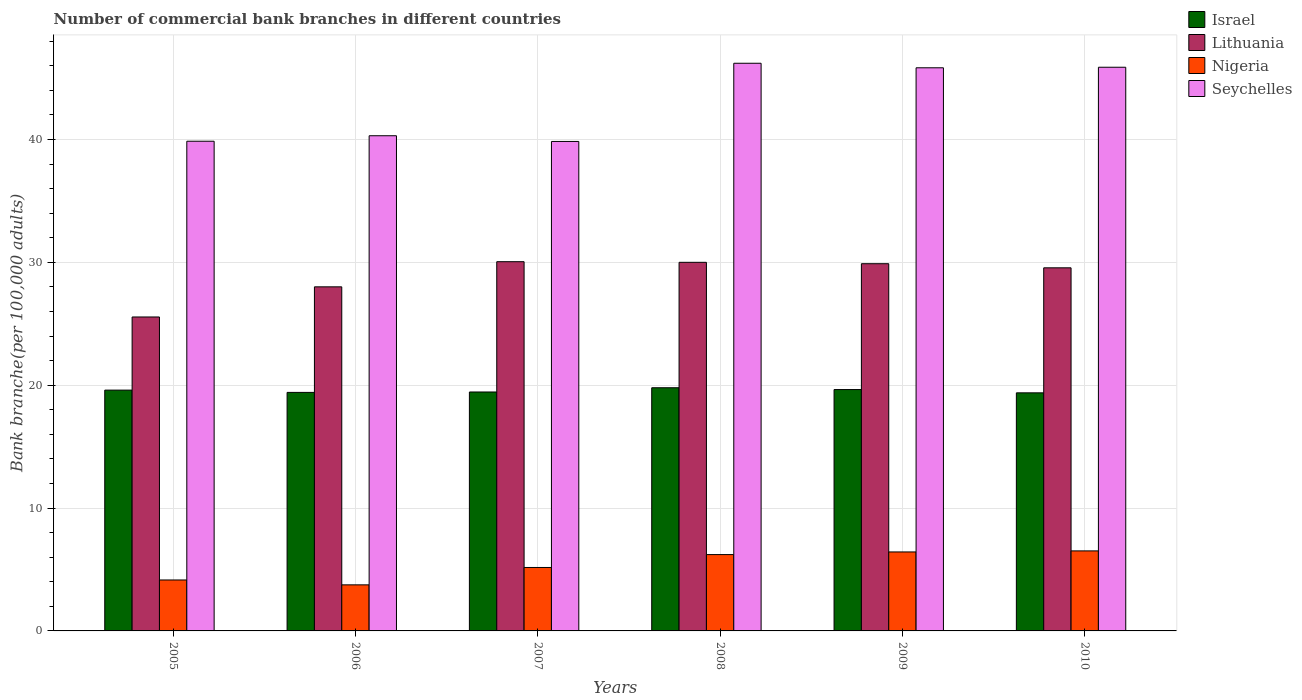How many different coloured bars are there?
Offer a terse response. 4. How many groups of bars are there?
Provide a succinct answer. 6. Are the number of bars on each tick of the X-axis equal?
Your answer should be compact. Yes. How many bars are there on the 5th tick from the right?
Give a very brief answer. 4. What is the label of the 4th group of bars from the left?
Provide a short and direct response. 2008. In how many cases, is the number of bars for a given year not equal to the number of legend labels?
Your answer should be compact. 0. What is the number of commercial bank branches in Lithuania in 2008?
Give a very brief answer. 30. Across all years, what is the maximum number of commercial bank branches in Seychelles?
Your answer should be very brief. 46.21. Across all years, what is the minimum number of commercial bank branches in Nigeria?
Your answer should be compact. 3.75. What is the total number of commercial bank branches in Nigeria in the graph?
Your response must be concise. 32.22. What is the difference between the number of commercial bank branches in Nigeria in 2008 and that in 2010?
Offer a very short reply. -0.3. What is the difference between the number of commercial bank branches in Nigeria in 2009 and the number of commercial bank branches in Israel in 2006?
Offer a terse response. -12.99. What is the average number of commercial bank branches in Lithuania per year?
Your response must be concise. 28.84. In the year 2006, what is the difference between the number of commercial bank branches in Seychelles and number of commercial bank branches in Lithuania?
Your answer should be compact. 12.3. In how many years, is the number of commercial bank branches in Lithuania greater than 38?
Your answer should be compact. 0. What is the ratio of the number of commercial bank branches in Seychelles in 2005 to that in 2010?
Ensure brevity in your answer.  0.87. Is the difference between the number of commercial bank branches in Seychelles in 2007 and 2010 greater than the difference between the number of commercial bank branches in Lithuania in 2007 and 2010?
Keep it short and to the point. No. What is the difference between the highest and the second highest number of commercial bank branches in Israel?
Offer a terse response. 0.15. What is the difference between the highest and the lowest number of commercial bank branches in Nigeria?
Your answer should be compact. 2.76. In how many years, is the number of commercial bank branches in Seychelles greater than the average number of commercial bank branches in Seychelles taken over all years?
Give a very brief answer. 3. What does the 1st bar from the left in 2009 represents?
Your answer should be compact. Israel. Is it the case that in every year, the sum of the number of commercial bank branches in Israel and number of commercial bank branches in Nigeria is greater than the number of commercial bank branches in Seychelles?
Offer a very short reply. No. How many years are there in the graph?
Offer a very short reply. 6. Are the values on the major ticks of Y-axis written in scientific E-notation?
Give a very brief answer. No. Does the graph contain any zero values?
Make the answer very short. No. Does the graph contain grids?
Give a very brief answer. Yes. Where does the legend appear in the graph?
Ensure brevity in your answer.  Top right. How are the legend labels stacked?
Your answer should be very brief. Vertical. What is the title of the graph?
Make the answer very short. Number of commercial bank branches in different countries. What is the label or title of the X-axis?
Offer a terse response. Years. What is the label or title of the Y-axis?
Offer a very short reply. Bank branche(per 100,0 adults). What is the Bank branche(per 100,000 adults) of Israel in 2005?
Offer a terse response. 19.6. What is the Bank branche(per 100,000 adults) of Lithuania in 2005?
Provide a short and direct response. 25.55. What is the Bank branche(per 100,000 adults) of Nigeria in 2005?
Provide a short and direct response. 4.15. What is the Bank branche(per 100,000 adults) in Seychelles in 2005?
Keep it short and to the point. 39.86. What is the Bank branche(per 100,000 adults) of Israel in 2006?
Your answer should be compact. 19.42. What is the Bank branche(per 100,000 adults) in Lithuania in 2006?
Provide a succinct answer. 28.01. What is the Bank branche(per 100,000 adults) in Nigeria in 2006?
Offer a very short reply. 3.75. What is the Bank branche(per 100,000 adults) in Seychelles in 2006?
Keep it short and to the point. 40.31. What is the Bank branche(per 100,000 adults) of Israel in 2007?
Keep it short and to the point. 19.45. What is the Bank branche(per 100,000 adults) of Lithuania in 2007?
Offer a very short reply. 30.05. What is the Bank branche(per 100,000 adults) in Nigeria in 2007?
Offer a terse response. 5.16. What is the Bank branche(per 100,000 adults) of Seychelles in 2007?
Offer a terse response. 39.84. What is the Bank branche(per 100,000 adults) of Israel in 2008?
Ensure brevity in your answer.  19.79. What is the Bank branche(per 100,000 adults) in Lithuania in 2008?
Your answer should be very brief. 30. What is the Bank branche(per 100,000 adults) in Nigeria in 2008?
Offer a very short reply. 6.21. What is the Bank branche(per 100,000 adults) of Seychelles in 2008?
Your answer should be compact. 46.21. What is the Bank branche(per 100,000 adults) of Israel in 2009?
Make the answer very short. 19.65. What is the Bank branche(per 100,000 adults) of Lithuania in 2009?
Provide a succinct answer. 29.89. What is the Bank branche(per 100,000 adults) of Nigeria in 2009?
Offer a very short reply. 6.43. What is the Bank branche(per 100,000 adults) of Seychelles in 2009?
Your answer should be very brief. 45.84. What is the Bank branche(per 100,000 adults) in Israel in 2010?
Offer a very short reply. 19.38. What is the Bank branche(per 100,000 adults) of Lithuania in 2010?
Keep it short and to the point. 29.56. What is the Bank branche(per 100,000 adults) of Nigeria in 2010?
Ensure brevity in your answer.  6.51. What is the Bank branche(per 100,000 adults) in Seychelles in 2010?
Your answer should be very brief. 45.88. Across all years, what is the maximum Bank branche(per 100,000 adults) of Israel?
Offer a very short reply. 19.79. Across all years, what is the maximum Bank branche(per 100,000 adults) in Lithuania?
Offer a terse response. 30.05. Across all years, what is the maximum Bank branche(per 100,000 adults) of Nigeria?
Offer a very short reply. 6.51. Across all years, what is the maximum Bank branche(per 100,000 adults) of Seychelles?
Offer a terse response. 46.21. Across all years, what is the minimum Bank branche(per 100,000 adults) of Israel?
Offer a very short reply. 19.38. Across all years, what is the minimum Bank branche(per 100,000 adults) of Lithuania?
Offer a very short reply. 25.55. Across all years, what is the minimum Bank branche(per 100,000 adults) in Nigeria?
Offer a terse response. 3.75. Across all years, what is the minimum Bank branche(per 100,000 adults) in Seychelles?
Keep it short and to the point. 39.84. What is the total Bank branche(per 100,000 adults) of Israel in the graph?
Offer a terse response. 117.29. What is the total Bank branche(per 100,000 adults) of Lithuania in the graph?
Ensure brevity in your answer.  173.07. What is the total Bank branche(per 100,000 adults) of Nigeria in the graph?
Your answer should be compact. 32.22. What is the total Bank branche(per 100,000 adults) of Seychelles in the graph?
Give a very brief answer. 257.94. What is the difference between the Bank branche(per 100,000 adults) of Israel in 2005 and that in 2006?
Keep it short and to the point. 0.18. What is the difference between the Bank branche(per 100,000 adults) of Lithuania in 2005 and that in 2006?
Your answer should be compact. -2.45. What is the difference between the Bank branche(per 100,000 adults) in Nigeria in 2005 and that in 2006?
Make the answer very short. 0.4. What is the difference between the Bank branche(per 100,000 adults) in Seychelles in 2005 and that in 2006?
Ensure brevity in your answer.  -0.45. What is the difference between the Bank branche(per 100,000 adults) of Israel in 2005 and that in 2007?
Your answer should be very brief. 0.15. What is the difference between the Bank branche(per 100,000 adults) of Nigeria in 2005 and that in 2007?
Offer a very short reply. -1.02. What is the difference between the Bank branche(per 100,000 adults) of Seychelles in 2005 and that in 2007?
Offer a terse response. 0.02. What is the difference between the Bank branche(per 100,000 adults) in Israel in 2005 and that in 2008?
Keep it short and to the point. -0.19. What is the difference between the Bank branche(per 100,000 adults) of Lithuania in 2005 and that in 2008?
Your response must be concise. -4.45. What is the difference between the Bank branche(per 100,000 adults) of Nigeria in 2005 and that in 2008?
Ensure brevity in your answer.  -2.07. What is the difference between the Bank branche(per 100,000 adults) in Seychelles in 2005 and that in 2008?
Your response must be concise. -6.35. What is the difference between the Bank branche(per 100,000 adults) in Israel in 2005 and that in 2009?
Offer a terse response. -0.05. What is the difference between the Bank branche(per 100,000 adults) of Lithuania in 2005 and that in 2009?
Make the answer very short. -4.34. What is the difference between the Bank branche(per 100,000 adults) of Nigeria in 2005 and that in 2009?
Provide a short and direct response. -2.28. What is the difference between the Bank branche(per 100,000 adults) in Seychelles in 2005 and that in 2009?
Provide a short and direct response. -5.98. What is the difference between the Bank branche(per 100,000 adults) in Israel in 2005 and that in 2010?
Give a very brief answer. 0.22. What is the difference between the Bank branche(per 100,000 adults) in Lithuania in 2005 and that in 2010?
Ensure brevity in your answer.  -4. What is the difference between the Bank branche(per 100,000 adults) in Nigeria in 2005 and that in 2010?
Offer a terse response. -2.37. What is the difference between the Bank branche(per 100,000 adults) of Seychelles in 2005 and that in 2010?
Your response must be concise. -6.02. What is the difference between the Bank branche(per 100,000 adults) in Israel in 2006 and that in 2007?
Offer a very short reply. -0.03. What is the difference between the Bank branche(per 100,000 adults) in Lithuania in 2006 and that in 2007?
Your answer should be compact. -2.05. What is the difference between the Bank branche(per 100,000 adults) in Nigeria in 2006 and that in 2007?
Keep it short and to the point. -1.41. What is the difference between the Bank branche(per 100,000 adults) in Seychelles in 2006 and that in 2007?
Provide a succinct answer. 0.46. What is the difference between the Bank branche(per 100,000 adults) in Israel in 2006 and that in 2008?
Keep it short and to the point. -0.38. What is the difference between the Bank branche(per 100,000 adults) in Lithuania in 2006 and that in 2008?
Make the answer very short. -2. What is the difference between the Bank branche(per 100,000 adults) in Nigeria in 2006 and that in 2008?
Ensure brevity in your answer.  -2.46. What is the difference between the Bank branche(per 100,000 adults) in Seychelles in 2006 and that in 2008?
Offer a terse response. -5.9. What is the difference between the Bank branche(per 100,000 adults) in Israel in 2006 and that in 2009?
Your response must be concise. -0.23. What is the difference between the Bank branche(per 100,000 adults) in Lithuania in 2006 and that in 2009?
Make the answer very short. -1.88. What is the difference between the Bank branche(per 100,000 adults) of Nigeria in 2006 and that in 2009?
Provide a succinct answer. -2.68. What is the difference between the Bank branche(per 100,000 adults) in Seychelles in 2006 and that in 2009?
Offer a very short reply. -5.53. What is the difference between the Bank branche(per 100,000 adults) in Israel in 2006 and that in 2010?
Offer a very short reply. 0.04. What is the difference between the Bank branche(per 100,000 adults) in Lithuania in 2006 and that in 2010?
Offer a very short reply. -1.55. What is the difference between the Bank branche(per 100,000 adults) in Nigeria in 2006 and that in 2010?
Give a very brief answer. -2.76. What is the difference between the Bank branche(per 100,000 adults) of Seychelles in 2006 and that in 2010?
Your answer should be very brief. -5.58. What is the difference between the Bank branche(per 100,000 adults) of Israel in 2007 and that in 2008?
Provide a short and direct response. -0.35. What is the difference between the Bank branche(per 100,000 adults) of Lithuania in 2007 and that in 2008?
Your response must be concise. 0.05. What is the difference between the Bank branche(per 100,000 adults) in Nigeria in 2007 and that in 2008?
Offer a very short reply. -1.05. What is the difference between the Bank branche(per 100,000 adults) in Seychelles in 2007 and that in 2008?
Make the answer very short. -6.36. What is the difference between the Bank branche(per 100,000 adults) of Israel in 2007 and that in 2009?
Your response must be concise. -0.2. What is the difference between the Bank branche(per 100,000 adults) of Lithuania in 2007 and that in 2009?
Your answer should be compact. 0.16. What is the difference between the Bank branche(per 100,000 adults) of Nigeria in 2007 and that in 2009?
Ensure brevity in your answer.  -1.26. What is the difference between the Bank branche(per 100,000 adults) in Seychelles in 2007 and that in 2009?
Ensure brevity in your answer.  -6. What is the difference between the Bank branche(per 100,000 adults) in Israel in 2007 and that in 2010?
Give a very brief answer. 0.07. What is the difference between the Bank branche(per 100,000 adults) in Lithuania in 2007 and that in 2010?
Give a very brief answer. 0.5. What is the difference between the Bank branche(per 100,000 adults) of Nigeria in 2007 and that in 2010?
Ensure brevity in your answer.  -1.35. What is the difference between the Bank branche(per 100,000 adults) of Seychelles in 2007 and that in 2010?
Give a very brief answer. -6.04. What is the difference between the Bank branche(per 100,000 adults) in Israel in 2008 and that in 2009?
Provide a short and direct response. 0.15. What is the difference between the Bank branche(per 100,000 adults) of Lithuania in 2008 and that in 2009?
Make the answer very short. 0.11. What is the difference between the Bank branche(per 100,000 adults) of Nigeria in 2008 and that in 2009?
Your response must be concise. -0.21. What is the difference between the Bank branche(per 100,000 adults) of Seychelles in 2008 and that in 2009?
Keep it short and to the point. 0.37. What is the difference between the Bank branche(per 100,000 adults) in Israel in 2008 and that in 2010?
Make the answer very short. 0.42. What is the difference between the Bank branche(per 100,000 adults) of Lithuania in 2008 and that in 2010?
Keep it short and to the point. 0.45. What is the difference between the Bank branche(per 100,000 adults) of Nigeria in 2008 and that in 2010?
Your answer should be very brief. -0.3. What is the difference between the Bank branche(per 100,000 adults) in Seychelles in 2008 and that in 2010?
Provide a short and direct response. 0.32. What is the difference between the Bank branche(per 100,000 adults) of Israel in 2009 and that in 2010?
Offer a very short reply. 0.27. What is the difference between the Bank branche(per 100,000 adults) in Lithuania in 2009 and that in 2010?
Offer a very short reply. 0.33. What is the difference between the Bank branche(per 100,000 adults) of Nigeria in 2009 and that in 2010?
Offer a very short reply. -0.08. What is the difference between the Bank branche(per 100,000 adults) in Seychelles in 2009 and that in 2010?
Keep it short and to the point. -0.05. What is the difference between the Bank branche(per 100,000 adults) in Israel in 2005 and the Bank branche(per 100,000 adults) in Lithuania in 2006?
Give a very brief answer. -8.41. What is the difference between the Bank branche(per 100,000 adults) in Israel in 2005 and the Bank branche(per 100,000 adults) in Nigeria in 2006?
Your answer should be very brief. 15.85. What is the difference between the Bank branche(per 100,000 adults) in Israel in 2005 and the Bank branche(per 100,000 adults) in Seychelles in 2006?
Offer a very short reply. -20.71. What is the difference between the Bank branche(per 100,000 adults) in Lithuania in 2005 and the Bank branche(per 100,000 adults) in Nigeria in 2006?
Your answer should be very brief. 21.81. What is the difference between the Bank branche(per 100,000 adults) in Lithuania in 2005 and the Bank branche(per 100,000 adults) in Seychelles in 2006?
Your answer should be compact. -14.75. What is the difference between the Bank branche(per 100,000 adults) of Nigeria in 2005 and the Bank branche(per 100,000 adults) of Seychelles in 2006?
Provide a short and direct response. -36.16. What is the difference between the Bank branche(per 100,000 adults) of Israel in 2005 and the Bank branche(per 100,000 adults) of Lithuania in 2007?
Provide a succinct answer. -10.45. What is the difference between the Bank branche(per 100,000 adults) of Israel in 2005 and the Bank branche(per 100,000 adults) of Nigeria in 2007?
Offer a terse response. 14.44. What is the difference between the Bank branche(per 100,000 adults) in Israel in 2005 and the Bank branche(per 100,000 adults) in Seychelles in 2007?
Keep it short and to the point. -20.24. What is the difference between the Bank branche(per 100,000 adults) in Lithuania in 2005 and the Bank branche(per 100,000 adults) in Nigeria in 2007?
Provide a short and direct response. 20.39. What is the difference between the Bank branche(per 100,000 adults) in Lithuania in 2005 and the Bank branche(per 100,000 adults) in Seychelles in 2007?
Provide a short and direct response. -14.29. What is the difference between the Bank branche(per 100,000 adults) of Nigeria in 2005 and the Bank branche(per 100,000 adults) of Seychelles in 2007?
Make the answer very short. -35.7. What is the difference between the Bank branche(per 100,000 adults) of Israel in 2005 and the Bank branche(per 100,000 adults) of Lithuania in 2008?
Your answer should be compact. -10.4. What is the difference between the Bank branche(per 100,000 adults) of Israel in 2005 and the Bank branche(per 100,000 adults) of Nigeria in 2008?
Offer a terse response. 13.39. What is the difference between the Bank branche(per 100,000 adults) of Israel in 2005 and the Bank branche(per 100,000 adults) of Seychelles in 2008?
Give a very brief answer. -26.61. What is the difference between the Bank branche(per 100,000 adults) of Lithuania in 2005 and the Bank branche(per 100,000 adults) of Nigeria in 2008?
Your answer should be compact. 19.34. What is the difference between the Bank branche(per 100,000 adults) in Lithuania in 2005 and the Bank branche(per 100,000 adults) in Seychelles in 2008?
Keep it short and to the point. -20.65. What is the difference between the Bank branche(per 100,000 adults) in Nigeria in 2005 and the Bank branche(per 100,000 adults) in Seychelles in 2008?
Provide a succinct answer. -42.06. What is the difference between the Bank branche(per 100,000 adults) of Israel in 2005 and the Bank branche(per 100,000 adults) of Lithuania in 2009?
Provide a succinct answer. -10.29. What is the difference between the Bank branche(per 100,000 adults) in Israel in 2005 and the Bank branche(per 100,000 adults) in Nigeria in 2009?
Your response must be concise. 13.17. What is the difference between the Bank branche(per 100,000 adults) in Israel in 2005 and the Bank branche(per 100,000 adults) in Seychelles in 2009?
Ensure brevity in your answer.  -26.24. What is the difference between the Bank branche(per 100,000 adults) of Lithuania in 2005 and the Bank branche(per 100,000 adults) of Nigeria in 2009?
Keep it short and to the point. 19.13. What is the difference between the Bank branche(per 100,000 adults) of Lithuania in 2005 and the Bank branche(per 100,000 adults) of Seychelles in 2009?
Your answer should be very brief. -20.28. What is the difference between the Bank branche(per 100,000 adults) in Nigeria in 2005 and the Bank branche(per 100,000 adults) in Seychelles in 2009?
Your answer should be compact. -41.69. What is the difference between the Bank branche(per 100,000 adults) in Israel in 2005 and the Bank branche(per 100,000 adults) in Lithuania in 2010?
Your answer should be very brief. -9.96. What is the difference between the Bank branche(per 100,000 adults) in Israel in 2005 and the Bank branche(per 100,000 adults) in Nigeria in 2010?
Give a very brief answer. 13.09. What is the difference between the Bank branche(per 100,000 adults) in Israel in 2005 and the Bank branche(per 100,000 adults) in Seychelles in 2010?
Make the answer very short. -26.28. What is the difference between the Bank branche(per 100,000 adults) in Lithuania in 2005 and the Bank branche(per 100,000 adults) in Nigeria in 2010?
Offer a terse response. 19.04. What is the difference between the Bank branche(per 100,000 adults) of Lithuania in 2005 and the Bank branche(per 100,000 adults) of Seychelles in 2010?
Your answer should be compact. -20.33. What is the difference between the Bank branche(per 100,000 adults) of Nigeria in 2005 and the Bank branche(per 100,000 adults) of Seychelles in 2010?
Give a very brief answer. -41.74. What is the difference between the Bank branche(per 100,000 adults) in Israel in 2006 and the Bank branche(per 100,000 adults) in Lithuania in 2007?
Provide a short and direct response. -10.64. What is the difference between the Bank branche(per 100,000 adults) of Israel in 2006 and the Bank branche(per 100,000 adults) of Nigeria in 2007?
Your answer should be compact. 14.25. What is the difference between the Bank branche(per 100,000 adults) of Israel in 2006 and the Bank branche(per 100,000 adults) of Seychelles in 2007?
Your answer should be compact. -20.43. What is the difference between the Bank branche(per 100,000 adults) in Lithuania in 2006 and the Bank branche(per 100,000 adults) in Nigeria in 2007?
Make the answer very short. 22.84. What is the difference between the Bank branche(per 100,000 adults) of Lithuania in 2006 and the Bank branche(per 100,000 adults) of Seychelles in 2007?
Make the answer very short. -11.83. What is the difference between the Bank branche(per 100,000 adults) of Nigeria in 2006 and the Bank branche(per 100,000 adults) of Seychelles in 2007?
Provide a short and direct response. -36.09. What is the difference between the Bank branche(per 100,000 adults) in Israel in 2006 and the Bank branche(per 100,000 adults) in Lithuania in 2008?
Provide a succinct answer. -10.59. What is the difference between the Bank branche(per 100,000 adults) in Israel in 2006 and the Bank branche(per 100,000 adults) in Nigeria in 2008?
Your answer should be very brief. 13.2. What is the difference between the Bank branche(per 100,000 adults) of Israel in 2006 and the Bank branche(per 100,000 adults) of Seychelles in 2008?
Your answer should be compact. -26.79. What is the difference between the Bank branche(per 100,000 adults) in Lithuania in 2006 and the Bank branche(per 100,000 adults) in Nigeria in 2008?
Provide a short and direct response. 21.79. What is the difference between the Bank branche(per 100,000 adults) in Lithuania in 2006 and the Bank branche(per 100,000 adults) in Seychelles in 2008?
Ensure brevity in your answer.  -18.2. What is the difference between the Bank branche(per 100,000 adults) in Nigeria in 2006 and the Bank branche(per 100,000 adults) in Seychelles in 2008?
Offer a very short reply. -42.46. What is the difference between the Bank branche(per 100,000 adults) of Israel in 2006 and the Bank branche(per 100,000 adults) of Lithuania in 2009?
Your answer should be compact. -10.47. What is the difference between the Bank branche(per 100,000 adults) in Israel in 2006 and the Bank branche(per 100,000 adults) in Nigeria in 2009?
Your response must be concise. 12.99. What is the difference between the Bank branche(per 100,000 adults) in Israel in 2006 and the Bank branche(per 100,000 adults) in Seychelles in 2009?
Offer a terse response. -26.42. What is the difference between the Bank branche(per 100,000 adults) of Lithuania in 2006 and the Bank branche(per 100,000 adults) of Nigeria in 2009?
Give a very brief answer. 21.58. What is the difference between the Bank branche(per 100,000 adults) of Lithuania in 2006 and the Bank branche(per 100,000 adults) of Seychelles in 2009?
Offer a very short reply. -17.83. What is the difference between the Bank branche(per 100,000 adults) of Nigeria in 2006 and the Bank branche(per 100,000 adults) of Seychelles in 2009?
Your answer should be very brief. -42.09. What is the difference between the Bank branche(per 100,000 adults) of Israel in 2006 and the Bank branche(per 100,000 adults) of Lithuania in 2010?
Your answer should be compact. -10.14. What is the difference between the Bank branche(per 100,000 adults) of Israel in 2006 and the Bank branche(per 100,000 adults) of Nigeria in 2010?
Make the answer very short. 12.9. What is the difference between the Bank branche(per 100,000 adults) in Israel in 2006 and the Bank branche(per 100,000 adults) in Seychelles in 2010?
Your response must be concise. -26.47. What is the difference between the Bank branche(per 100,000 adults) of Lithuania in 2006 and the Bank branche(per 100,000 adults) of Nigeria in 2010?
Give a very brief answer. 21.5. What is the difference between the Bank branche(per 100,000 adults) of Lithuania in 2006 and the Bank branche(per 100,000 adults) of Seychelles in 2010?
Provide a succinct answer. -17.88. What is the difference between the Bank branche(per 100,000 adults) in Nigeria in 2006 and the Bank branche(per 100,000 adults) in Seychelles in 2010?
Provide a short and direct response. -42.13. What is the difference between the Bank branche(per 100,000 adults) of Israel in 2007 and the Bank branche(per 100,000 adults) of Lithuania in 2008?
Offer a very short reply. -10.55. What is the difference between the Bank branche(per 100,000 adults) of Israel in 2007 and the Bank branche(per 100,000 adults) of Nigeria in 2008?
Offer a terse response. 13.23. What is the difference between the Bank branche(per 100,000 adults) in Israel in 2007 and the Bank branche(per 100,000 adults) in Seychelles in 2008?
Provide a succinct answer. -26.76. What is the difference between the Bank branche(per 100,000 adults) of Lithuania in 2007 and the Bank branche(per 100,000 adults) of Nigeria in 2008?
Offer a terse response. 23.84. What is the difference between the Bank branche(per 100,000 adults) of Lithuania in 2007 and the Bank branche(per 100,000 adults) of Seychelles in 2008?
Offer a terse response. -16.15. What is the difference between the Bank branche(per 100,000 adults) of Nigeria in 2007 and the Bank branche(per 100,000 adults) of Seychelles in 2008?
Your response must be concise. -41.04. What is the difference between the Bank branche(per 100,000 adults) of Israel in 2007 and the Bank branche(per 100,000 adults) of Lithuania in 2009?
Provide a short and direct response. -10.44. What is the difference between the Bank branche(per 100,000 adults) in Israel in 2007 and the Bank branche(per 100,000 adults) in Nigeria in 2009?
Your response must be concise. 13.02. What is the difference between the Bank branche(per 100,000 adults) in Israel in 2007 and the Bank branche(per 100,000 adults) in Seychelles in 2009?
Keep it short and to the point. -26.39. What is the difference between the Bank branche(per 100,000 adults) of Lithuania in 2007 and the Bank branche(per 100,000 adults) of Nigeria in 2009?
Your answer should be very brief. 23.63. What is the difference between the Bank branche(per 100,000 adults) of Lithuania in 2007 and the Bank branche(per 100,000 adults) of Seychelles in 2009?
Give a very brief answer. -15.78. What is the difference between the Bank branche(per 100,000 adults) in Nigeria in 2007 and the Bank branche(per 100,000 adults) in Seychelles in 2009?
Your answer should be very brief. -40.67. What is the difference between the Bank branche(per 100,000 adults) of Israel in 2007 and the Bank branche(per 100,000 adults) of Lithuania in 2010?
Your answer should be compact. -10.11. What is the difference between the Bank branche(per 100,000 adults) of Israel in 2007 and the Bank branche(per 100,000 adults) of Nigeria in 2010?
Your answer should be compact. 12.94. What is the difference between the Bank branche(per 100,000 adults) in Israel in 2007 and the Bank branche(per 100,000 adults) in Seychelles in 2010?
Make the answer very short. -26.43. What is the difference between the Bank branche(per 100,000 adults) of Lithuania in 2007 and the Bank branche(per 100,000 adults) of Nigeria in 2010?
Offer a very short reply. 23.54. What is the difference between the Bank branche(per 100,000 adults) of Lithuania in 2007 and the Bank branche(per 100,000 adults) of Seychelles in 2010?
Your answer should be very brief. -15.83. What is the difference between the Bank branche(per 100,000 adults) of Nigeria in 2007 and the Bank branche(per 100,000 adults) of Seychelles in 2010?
Make the answer very short. -40.72. What is the difference between the Bank branche(per 100,000 adults) of Israel in 2008 and the Bank branche(per 100,000 adults) of Lithuania in 2009?
Offer a very short reply. -10.1. What is the difference between the Bank branche(per 100,000 adults) of Israel in 2008 and the Bank branche(per 100,000 adults) of Nigeria in 2009?
Offer a terse response. 13.37. What is the difference between the Bank branche(per 100,000 adults) of Israel in 2008 and the Bank branche(per 100,000 adults) of Seychelles in 2009?
Ensure brevity in your answer.  -26.04. What is the difference between the Bank branche(per 100,000 adults) in Lithuania in 2008 and the Bank branche(per 100,000 adults) in Nigeria in 2009?
Your answer should be compact. 23.57. What is the difference between the Bank branche(per 100,000 adults) in Lithuania in 2008 and the Bank branche(per 100,000 adults) in Seychelles in 2009?
Keep it short and to the point. -15.83. What is the difference between the Bank branche(per 100,000 adults) in Nigeria in 2008 and the Bank branche(per 100,000 adults) in Seychelles in 2009?
Ensure brevity in your answer.  -39.62. What is the difference between the Bank branche(per 100,000 adults) in Israel in 2008 and the Bank branche(per 100,000 adults) in Lithuania in 2010?
Offer a very short reply. -9.76. What is the difference between the Bank branche(per 100,000 adults) of Israel in 2008 and the Bank branche(per 100,000 adults) of Nigeria in 2010?
Provide a succinct answer. 13.28. What is the difference between the Bank branche(per 100,000 adults) of Israel in 2008 and the Bank branche(per 100,000 adults) of Seychelles in 2010?
Ensure brevity in your answer.  -26.09. What is the difference between the Bank branche(per 100,000 adults) of Lithuania in 2008 and the Bank branche(per 100,000 adults) of Nigeria in 2010?
Provide a short and direct response. 23.49. What is the difference between the Bank branche(per 100,000 adults) of Lithuania in 2008 and the Bank branche(per 100,000 adults) of Seychelles in 2010?
Offer a very short reply. -15.88. What is the difference between the Bank branche(per 100,000 adults) of Nigeria in 2008 and the Bank branche(per 100,000 adults) of Seychelles in 2010?
Your response must be concise. -39.67. What is the difference between the Bank branche(per 100,000 adults) of Israel in 2009 and the Bank branche(per 100,000 adults) of Lithuania in 2010?
Provide a short and direct response. -9.91. What is the difference between the Bank branche(per 100,000 adults) in Israel in 2009 and the Bank branche(per 100,000 adults) in Nigeria in 2010?
Your response must be concise. 13.13. What is the difference between the Bank branche(per 100,000 adults) in Israel in 2009 and the Bank branche(per 100,000 adults) in Seychelles in 2010?
Provide a short and direct response. -26.24. What is the difference between the Bank branche(per 100,000 adults) of Lithuania in 2009 and the Bank branche(per 100,000 adults) of Nigeria in 2010?
Offer a very short reply. 23.38. What is the difference between the Bank branche(per 100,000 adults) of Lithuania in 2009 and the Bank branche(per 100,000 adults) of Seychelles in 2010?
Ensure brevity in your answer.  -15.99. What is the difference between the Bank branche(per 100,000 adults) of Nigeria in 2009 and the Bank branche(per 100,000 adults) of Seychelles in 2010?
Ensure brevity in your answer.  -39.45. What is the average Bank branche(per 100,000 adults) in Israel per year?
Your response must be concise. 19.55. What is the average Bank branche(per 100,000 adults) of Lithuania per year?
Your response must be concise. 28.84. What is the average Bank branche(per 100,000 adults) of Nigeria per year?
Your answer should be compact. 5.37. What is the average Bank branche(per 100,000 adults) of Seychelles per year?
Your response must be concise. 42.99. In the year 2005, what is the difference between the Bank branche(per 100,000 adults) in Israel and Bank branche(per 100,000 adults) in Lithuania?
Your answer should be very brief. -5.95. In the year 2005, what is the difference between the Bank branche(per 100,000 adults) of Israel and Bank branche(per 100,000 adults) of Nigeria?
Keep it short and to the point. 15.45. In the year 2005, what is the difference between the Bank branche(per 100,000 adults) in Israel and Bank branche(per 100,000 adults) in Seychelles?
Give a very brief answer. -20.26. In the year 2005, what is the difference between the Bank branche(per 100,000 adults) in Lithuania and Bank branche(per 100,000 adults) in Nigeria?
Keep it short and to the point. 21.41. In the year 2005, what is the difference between the Bank branche(per 100,000 adults) of Lithuania and Bank branche(per 100,000 adults) of Seychelles?
Keep it short and to the point. -14.31. In the year 2005, what is the difference between the Bank branche(per 100,000 adults) of Nigeria and Bank branche(per 100,000 adults) of Seychelles?
Ensure brevity in your answer.  -35.71. In the year 2006, what is the difference between the Bank branche(per 100,000 adults) of Israel and Bank branche(per 100,000 adults) of Lithuania?
Provide a succinct answer. -8.59. In the year 2006, what is the difference between the Bank branche(per 100,000 adults) in Israel and Bank branche(per 100,000 adults) in Nigeria?
Provide a short and direct response. 15.67. In the year 2006, what is the difference between the Bank branche(per 100,000 adults) in Israel and Bank branche(per 100,000 adults) in Seychelles?
Ensure brevity in your answer.  -20.89. In the year 2006, what is the difference between the Bank branche(per 100,000 adults) of Lithuania and Bank branche(per 100,000 adults) of Nigeria?
Your response must be concise. 24.26. In the year 2006, what is the difference between the Bank branche(per 100,000 adults) of Lithuania and Bank branche(per 100,000 adults) of Seychelles?
Offer a very short reply. -12.3. In the year 2006, what is the difference between the Bank branche(per 100,000 adults) of Nigeria and Bank branche(per 100,000 adults) of Seychelles?
Provide a short and direct response. -36.56. In the year 2007, what is the difference between the Bank branche(per 100,000 adults) in Israel and Bank branche(per 100,000 adults) in Lithuania?
Provide a short and direct response. -10.61. In the year 2007, what is the difference between the Bank branche(per 100,000 adults) of Israel and Bank branche(per 100,000 adults) of Nigeria?
Your response must be concise. 14.28. In the year 2007, what is the difference between the Bank branche(per 100,000 adults) of Israel and Bank branche(per 100,000 adults) of Seychelles?
Your answer should be very brief. -20.39. In the year 2007, what is the difference between the Bank branche(per 100,000 adults) in Lithuania and Bank branche(per 100,000 adults) in Nigeria?
Keep it short and to the point. 24.89. In the year 2007, what is the difference between the Bank branche(per 100,000 adults) in Lithuania and Bank branche(per 100,000 adults) in Seychelles?
Your response must be concise. -9.79. In the year 2007, what is the difference between the Bank branche(per 100,000 adults) in Nigeria and Bank branche(per 100,000 adults) in Seychelles?
Your response must be concise. -34.68. In the year 2008, what is the difference between the Bank branche(per 100,000 adults) in Israel and Bank branche(per 100,000 adults) in Lithuania?
Your answer should be compact. -10.21. In the year 2008, what is the difference between the Bank branche(per 100,000 adults) of Israel and Bank branche(per 100,000 adults) of Nigeria?
Offer a terse response. 13.58. In the year 2008, what is the difference between the Bank branche(per 100,000 adults) of Israel and Bank branche(per 100,000 adults) of Seychelles?
Your answer should be very brief. -26.41. In the year 2008, what is the difference between the Bank branche(per 100,000 adults) in Lithuania and Bank branche(per 100,000 adults) in Nigeria?
Make the answer very short. 23.79. In the year 2008, what is the difference between the Bank branche(per 100,000 adults) of Lithuania and Bank branche(per 100,000 adults) of Seychelles?
Provide a succinct answer. -16.2. In the year 2008, what is the difference between the Bank branche(per 100,000 adults) of Nigeria and Bank branche(per 100,000 adults) of Seychelles?
Your response must be concise. -39.99. In the year 2009, what is the difference between the Bank branche(per 100,000 adults) in Israel and Bank branche(per 100,000 adults) in Lithuania?
Provide a short and direct response. -10.24. In the year 2009, what is the difference between the Bank branche(per 100,000 adults) of Israel and Bank branche(per 100,000 adults) of Nigeria?
Keep it short and to the point. 13.22. In the year 2009, what is the difference between the Bank branche(per 100,000 adults) in Israel and Bank branche(per 100,000 adults) in Seychelles?
Your answer should be compact. -26.19. In the year 2009, what is the difference between the Bank branche(per 100,000 adults) of Lithuania and Bank branche(per 100,000 adults) of Nigeria?
Make the answer very short. 23.46. In the year 2009, what is the difference between the Bank branche(per 100,000 adults) of Lithuania and Bank branche(per 100,000 adults) of Seychelles?
Give a very brief answer. -15.95. In the year 2009, what is the difference between the Bank branche(per 100,000 adults) in Nigeria and Bank branche(per 100,000 adults) in Seychelles?
Keep it short and to the point. -39.41. In the year 2010, what is the difference between the Bank branche(per 100,000 adults) of Israel and Bank branche(per 100,000 adults) of Lithuania?
Offer a very short reply. -10.18. In the year 2010, what is the difference between the Bank branche(per 100,000 adults) in Israel and Bank branche(per 100,000 adults) in Nigeria?
Your response must be concise. 12.87. In the year 2010, what is the difference between the Bank branche(per 100,000 adults) of Israel and Bank branche(per 100,000 adults) of Seychelles?
Make the answer very short. -26.5. In the year 2010, what is the difference between the Bank branche(per 100,000 adults) in Lithuania and Bank branche(per 100,000 adults) in Nigeria?
Offer a very short reply. 23.04. In the year 2010, what is the difference between the Bank branche(per 100,000 adults) of Lithuania and Bank branche(per 100,000 adults) of Seychelles?
Your response must be concise. -16.33. In the year 2010, what is the difference between the Bank branche(per 100,000 adults) in Nigeria and Bank branche(per 100,000 adults) in Seychelles?
Your answer should be very brief. -39.37. What is the ratio of the Bank branche(per 100,000 adults) of Israel in 2005 to that in 2006?
Offer a very short reply. 1.01. What is the ratio of the Bank branche(per 100,000 adults) of Lithuania in 2005 to that in 2006?
Provide a short and direct response. 0.91. What is the ratio of the Bank branche(per 100,000 adults) of Nigeria in 2005 to that in 2006?
Give a very brief answer. 1.11. What is the ratio of the Bank branche(per 100,000 adults) in Seychelles in 2005 to that in 2006?
Your answer should be very brief. 0.99. What is the ratio of the Bank branche(per 100,000 adults) in Lithuania in 2005 to that in 2007?
Your answer should be compact. 0.85. What is the ratio of the Bank branche(per 100,000 adults) in Nigeria in 2005 to that in 2007?
Give a very brief answer. 0.8. What is the ratio of the Bank branche(per 100,000 adults) in Seychelles in 2005 to that in 2007?
Offer a terse response. 1. What is the ratio of the Bank branche(per 100,000 adults) of Israel in 2005 to that in 2008?
Your response must be concise. 0.99. What is the ratio of the Bank branche(per 100,000 adults) of Lithuania in 2005 to that in 2008?
Offer a terse response. 0.85. What is the ratio of the Bank branche(per 100,000 adults) of Nigeria in 2005 to that in 2008?
Provide a short and direct response. 0.67. What is the ratio of the Bank branche(per 100,000 adults) in Seychelles in 2005 to that in 2008?
Provide a short and direct response. 0.86. What is the ratio of the Bank branche(per 100,000 adults) in Israel in 2005 to that in 2009?
Make the answer very short. 1. What is the ratio of the Bank branche(per 100,000 adults) in Lithuania in 2005 to that in 2009?
Your answer should be very brief. 0.85. What is the ratio of the Bank branche(per 100,000 adults) of Nigeria in 2005 to that in 2009?
Make the answer very short. 0.65. What is the ratio of the Bank branche(per 100,000 adults) in Seychelles in 2005 to that in 2009?
Provide a succinct answer. 0.87. What is the ratio of the Bank branche(per 100,000 adults) of Israel in 2005 to that in 2010?
Your answer should be very brief. 1.01. What is the ratio of the Bank branche(per 100,000 adults) of Lithuania in 2005 to that in 2010?
Offer a terse response. 0.86. What is the ratio of the Bank branche(per 100,000 adults) of Nigeria in 2005 to that in 2010?
Offer a very short reply. 0.64. What is the ratio of the Bank branche(per 100,000 adults) of Seychelles in 2005 to that in 2010?
Give a very brief answer. 0.87. What is the ratio of the Bank branche(per 100,000 adults) of Israel in 2006 to that in 2007?
Ensure brevity in your answer.  1. What is the ratio of the Bank branche(per 100,000 adults) in Lithuania in 2006 to that in 2007?
Offer a very short reply. 0.93. What is the ratio of the Bank branche(per 100,000 adults) of Nigeria in 2006 to that in 2007?
Your answer should be compact. 0.73. What is the ratio of the Bank branche(per 100,000 adults) in Seychelles in 2006 to that in 2007?
Your answer should be compact. 1.01. What is the ratio of the Bank branche(per 100,000 adults) of Israel in 2006 to that in 2008?
Keep it short and to the point. 0.98. What is the ratio of the Bank branche(per 100,000 adults) in Lithuania in 2006 to that in 2008?
Your response must be concise. 0.93. What is the ratio of the Bank branche(per 100,000 adults) in Nigeria in 2006 to that in 2008?
Provide a succinct answer. 0.6. What is the ratio of the Bank branche(per 100,000 adults) of Seychelles in 2006 to that in 2008?
Make the answer very short. 0.87. What is the ratio of the Bank branche(per 100,000 adults) in Israel in 2006 to that in 2009?
Your answer should be very brief. 0.99. What is the ratio of the Bank branche(per 100,000 adults) of Lithuania in 2006 to that in 2009?
Offer a terse response. 0.94. What is the ratio of the Bank branche(per 100,000 adults) in Nigeria in 2006 to that in 2009?
Make the answer very short. 0.58. What is the ratio of the Bank branche(per 100,000 adults) in Seychelles in 2006 to that in 2009?
Your answer should be very brief. 0.88. What is the ratio of the Bank branche(per 100,000 adults) in Lithuania in 2006 to that in 2010?
Offer a very short reply. 0.95. What is the ratio of the Bank branche(per 100,000 adults) of Nigeria in 2006 to that in 2010?
Ensure brevity in your answer.  0.58. What is the ratio of the Bank branche(per 100,000 adults) in Seychelles in 2006 to that in 2010?
Ensure brevity in your answer.  0.88. What is the ratio of the Bank branche(per 100,000 adults) in Israel in 2007 to that in 2008?
Provide a succinct answer. 0.98. What is the ratio of the Bank branche(per 100,000 adults) of Nigeria in 2007 to that in 2008?
Ensure brevity in your answer.  0.83. What is the ratio of the Bank branche(per 100,000 adults) of Seychelles in 2007 to that in 2008?
Give a very brief answer. 0.86. What is the ratio of the Bank branche(per 100,000 adults) in Lithuania in 2007 to that in 2009?
Offer a terse response. 1.01. What is the ratio of the Bank branche(per 100,000 adults) in Nigeria in 2007 to that in 2009?
Your answer should be very brief. 0.8. What is the ratio of the Bank branche(per 100,000 adults) in Seychelles in 2007 to that in 2009?
Make the answer very short. 0.87. What is the ratio of the Bank branche(per 100,000 adults) in Lithuania in 2007 to that in 2010?
Your answer should be very brief. 1.02. What is the ratio of the Bank branche(per 100,000 adults) in Nigeria in 2007 to that in 2010?
Your response must be concise. 0.79. What is the ratio of the Bank branche(per 100,000 adults) in Seychelles in 2007 to that in 2010?
Ensure brevity in your answer.  0.87. What is the ratio of the Bank branche(per 100,000 adults) of Israel in 2008 to that in 2009?
Your answer should be very brief. 1.01. What is the ratio of the Bank branche(per 100,000 adults) in Lithuania in 2008 to that in 2009?
Provide a succinct answer. 1. What is the ratio of the Bank branche(per 100,000 adults) of Nigeria in 2008 to that in 2009?
Your response must be concise. 0.97. What is the ratio of the Bank branche(per 100,000 adults) of Israel in 2008 to that in 2010?
Your answer should be compact. 1.02. What is the ratio of the Bank branche(per 100,000 adults) of Lithuania in 2008 to that in 2010?
Offer a terse response. 1.02. What is the ratio of the Bank branche(per 100,000 adults) of Nigeria in 2008 to that in 2010?
Your response must be concise. 0.95. What is the ratio of the Bank branche(per 100,000 adults) in Seychelles in 2008 to that in 2010?
Keep it short and to the point. 1.01. What is the ratio of the Bank branche(per 100,000 adults) in Israel in 2009 to that in 2010?
Make the answer very short. 1.01. What is the ratio of the Bank branche(per 100,000 adults) in Lithuania in 2009 to that in 2010?
Your answer should be very brief. 1.01. What is the difference between the highest and the second highest Bank branche(per 100,000 adults) of Israel?
Make the answer very short. 0.15. What is the difference between the highest and the second highest Bank branche(per 100,000 adults) of Lithuania?
Your answer should be compact. 0.05. What is the difference between the highest and the second highest Bank branche(per 100,000 adults) of Nigeria?
Keep it short and to the point. 0.08. What is the difference between the highest and the second highest Bank branche(per 100,000 adults) in Seychelles?
Offer a very short reply. 0.32. What is the difference between the highest and the lowest Bank branche(per 100,000 adults) in Israel?
Offer a terse response. 0.42. What is the difference between the highest and the lowest Bank branche(per 100,000 adults) in Lithuania?
Offer a very short reply. 4.5. What is the difference between the highest and the lowest Bank branche(per 100,000 adults) in Nigeria?
Offer a very short reply. 2.76. What is the difference between the highest and the lowest Bank branche(per 100,000 adults) in Seychelles?
Keep it short and to the point. 6.36. 